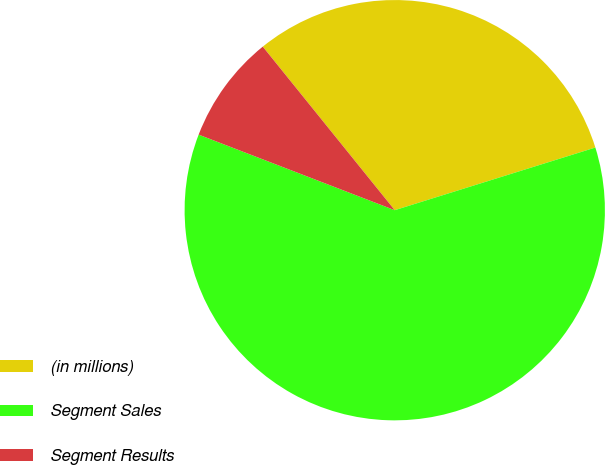Convert chart to OTSL. <chart><loc_0><loc_0><loc_500><loc_500><pie_chart><fcel>(in millions)<fcel>Segment Sales<fcel>Segment Results<nl><fcel>30.99%<fcel>60.67%<fcel>8.34%<nl></chart> 